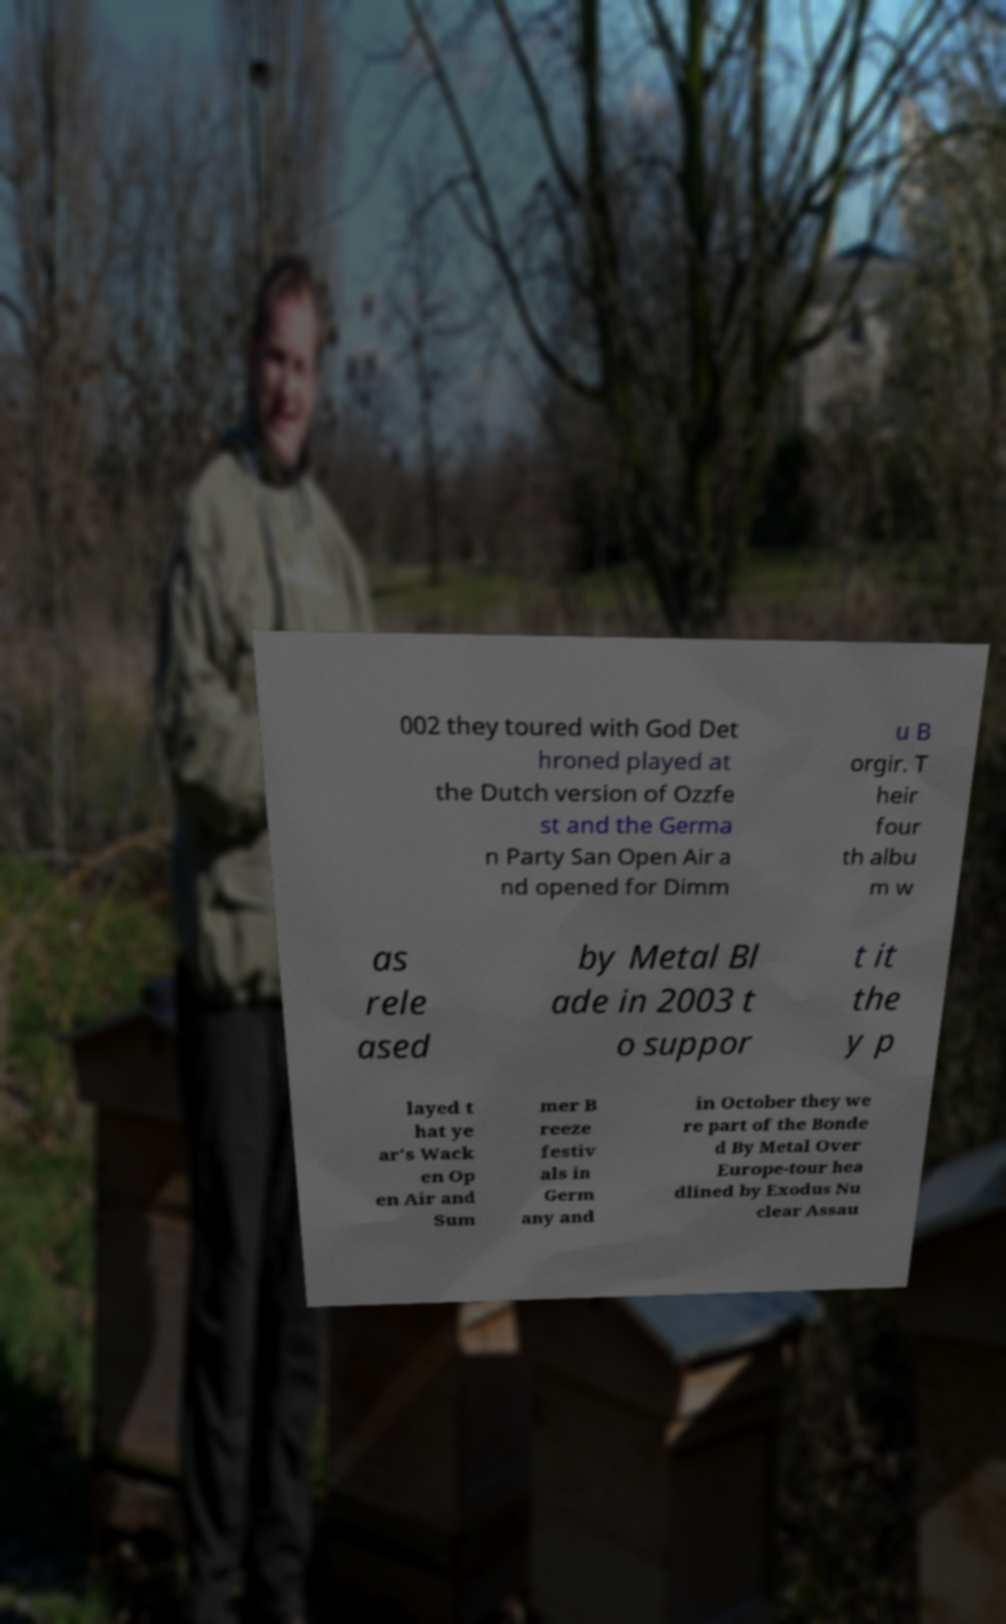For documentation purposes, I need the text within this image transcribed. Could you provide that? 002 they toured with God Det hroned played at the Dutch version of Ozzfe st and the Germa n Party San Open Air a nd opened for Dimm u B orgir. T heir four th albu m w as rele ased by Metal Bl ade in 2003 t o suppor t it the y p layed t hat ye ar's Wack en Op en Air and Sum mer B reeze festiv als in Germ any and in October they we re part of the Bonde d By Metal Over Europe-tour hea dlined by Exodus Nu clear Assau 